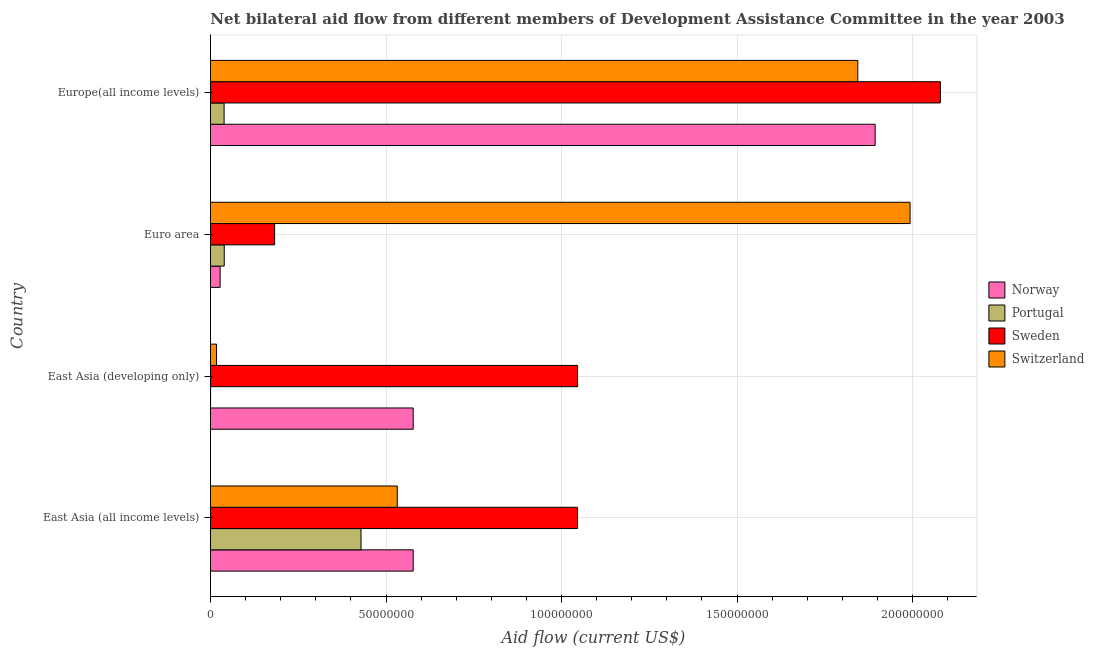Are the number of bars per tick equal to the number of legend labels?
Make the answer very short. Yes. Are the number of bars on each tick of the Y-axis equal?
Give a very brief answer. Yes. How many bars are there on the 4th tick from the top?
Offer a terse response. 4. How many bars are there on the 1st tick from the bottom?
Your answer should be very brief. 4. What is the label of the 3rd group of bars from the top?
Your response must be concise. East Asia (developing only). What is the amount of aid given by norway in East Asia (developing only)?
Ensure brevity in your answer.  5.78e+07. Across all countries, what is the maximum amount of aid given by portugal?
Provide a short and direct response. 4.29e+07. Across all countries, what is the minimum amount of aid given by portugal?
Your answer should be very brief. 3.00e+04. In which country was the amount of aid given by norway maximum?
Offer a very short reply. Europe(all income levels). In which country was the amount of aid given by norway minimum?
Offer a terse response. Euro area. What is the total amount of aid given by portugal in the graph?
Offer a very short reply. 5.07e+07. What is the difference between the amount of aid given by norway in Euro area and that in Europe(all income levels)?
Provide a short and direct response. -1.87e+08. What is the difference between the amount of aid given by sweden in Euro area and the amount of aid given by portugal in East Asia (developing only)?
Offer a very short reply. 1.82e+07. What is the average amount of aid given by sweden per country?
Provide a short and direct response. 1.09e+08. What is the difference between the amount of aid given by sweden and amount of aid given by norway in East Asia (all income levels)?
Ensure brevity in your answer.  4.68e+07. What is the ratio of the amount of aid given by portugal in East Asia (all income levels) to that in East Asia (developing only)?
Give a very brief answer. 1429.67. Is the difference between the amount of aid given by sweden in East Asia (all income levels) and East Asia (developing only) greater than the difference between the amount of aid given by switzerland in East Asia (all income levels) and East Asia (developing only)?
Your answer should be compact. No. What is the difference between the highest and the second highest amount of aid given by portugal?
Keep it short and to the point. 3.90e+07. What is the difference between the highest and the lowest amount of aid given by portugal?
Provide a succinct answer. 4.29e+07. In how many countries, is the amount of aid given by norway greater than the average amount of aid given by norway taken over all countries?
Make the answer very short. 1. Is the sum of the amount of aid given by norway in East Asia (all income levels) and Euro area greater than the maximum amount of aid given by switzerland across all countries?
Make the answer very short. No. Is it the case that in every country, the sum of the amount of aid given by norway and amount of aid given by switzerland is greater than the sum of amount of aid given by portugal and amount of aid given by sweden?
Offer a terse response. Yes. What does the 2nd bar from the top in East Asia (all income levels) represents?
Offer a terse response. Sweden. Are all the bars in the graph horizontal?
Your response must be concise. Yes. What is the difference between two consecutive major ticks on the X-axis?
Offer a terse response. 5.00e+07. Does the graph contain any zero values?
Your answer should be compact. No. Where does the legend appear in the graph?
Provide a short and direct response. Center right. How are the legend labels stacked?
Give a very brief answer. Vertical. What is the title of the graph?
Ensure brevity in your answer.  Net bilateral aid flow from different members of Development Assistance Committee in the year 2003. Does "Secondary general education" appear as one of the legend labels in the graph?
Provide a succinct answer. No. What is the label or title of the Y-axis?
Your answer should be very brief. Country. What is the Aid flow (current US$) in Norway in East Asia (all income levels)?
Provide a succinct answer. 5.78e+07. What is the Aid flow (current US$) of Portugal in East Asia (all income levels)?
Make the answer very short. 4.29e+07. What is the Aid flow (current US$) of Sweden in East Asia (all income levels)?
Ensure brevity in your answer.  1.05e+08. What is the Aid flow (current US$) of Switzerland in East Asia (all income levels)?
Ensure brevity in your answer.  5.32e+07. What is the Aid flow (current US$) in Norway in East Asia (developing only)?
Your answer should be compact. 5.78e+07. What is the Aid flow (current US$) in Portugal in East Asia (developing only)?
Your answer should be compact. 3.00e+04. What is the Aid flow (current US$) of Sweden in East Asia (developing only)?
Provide a succinct answer. 1.05e+08. What is the Aid flow (current US$) of Switzerland in East Asia (developing only)?
Your answer should be compact. 1.73e+06. What is the Aid flow (current US$) of Norway in Euro area?
Give a very brief answer. 2.75e+06. What is the Aid flow (current US$) of Portugal in Euro area?
Keep it short and to the point. 3.92e+06. What is the Aid flow (current US$) in Sweden in Euro area?
Provide a succinct answer. 1.83e+07. What is the Aid flow (current US$) in Switzerland in Euro area?
Your answer should be compact. 1.99e+08. What is the Aid flow (current US$) in Norway in Europe(all income levels)?
Make the answer very short. 1.89e+08. What is the Aid flow (current US$) of Portugal in Europe(all income levels)?
Your answer should be compact. 3.88e+06. What is the Aid flow (current US$) in Sweden in Europe(all income levels)?
Ensure brevity in your answer.  2.08e+08. What is the Aid flow (current US$) in Switzerland in Europe(all income levels)?
Ensure brevity in your answer.  1.84e+08. Across all countries, what is the maximum Aid flow (current US$) of Norway?
Ensure brevity in your answer.  1.89e+08. Across all countries, what is the maximum Aid flow (current US$) of Portugal?
Provide a short and direct response. 4.29e+07. Across all countries, what is the maximum Aid flow (current US$) of Sweden?
Your response must be concise. 2.08e+08. Across all countries, what is the maximum Aid flow (current US$) of Switzerland?
Ensure brevity in your answer.  1.99e+08. Across all countries, what is the minimum Aid flow (current US$) of Norway?
Ensure brevity in your answer.  2.75e+06. Across all countries, what is the minimum Aid flow (current US$) of Sweden?
Your response must be concise. 1.83e+07. Across all countries, what is the minimum Aid flow (current US$) of Switzerland?
Keep it short and to the point. 1.73e+06. What is the total Aid flow (current US$) in Norway in the graph?
Your response must be concise. 3.08e+08. What is the total Aid flow (current US$) of Portugal in the graph?
Offer a very short reply. 5.07e+07. What is the total Aid flow (current US$) of Sweden in the graph?
Your response must be concise. 4.35e+08. What is the total Aid flow (current US$) in Switzerland in the graph?
Offer a very short reply. 4.39e+08. What is the difference between the Aid flow (current US$) of Norway in East Asia (all income levels) and that in East Asia (developing only)?
Your response must be concise. 0. What is the difference between the Aid flow (current US$) of Portugal in East Asia (all income levels) and that in East Asia (developing only)?
Provide a succinct answer. 4.29e+07. What is the difference between the Aid flow (current US$) in Switzerland in East Asia (all income levels) and that in East Asia (developing only)?
Provide a short and direct response. 5.15e+07. What is the difference between the Aid flow (current US$) in Norway in East Asia (all income levels) and that in Euro area?
Your answer should be very brief. 5.50e+07. What is the difference between the Aid flow (current US$) of Portugal in East Asia (all income levels) and that in Euro area?
Ensure brevity in your answer.  3.90e+07. What is the difference between the Aid flow (current US$) in Sweden in East Asia (all income levels) and that in Euro area?
Your response must be concise. 8.63e+07. What is the difference between the Aid flow (current US$) in Switzerland in East Asia (all income levels) and that in Euro area?
Offer a terse response. -1.46e+08. What is the difference between the Aid flow (current US$) of Norway in East Asia (all income levels) and that in Europe(all income levels)?
Your answer should be compact. -1.32e+08. What is the difference between the Aid flow (current US$) of Portugal in East Asia (all income levels) and that in Europe(all income levels)?
Keep it short and to the point. 3.90e+07. What is the difference between the Aid flow (current US$) of Sweden in East Asia (all income levels) and that in Europe(all income levels)?
Provide a succinct answer. -1.03e+08. What is the difference between the Aid flow (current US$) in Switzerland in East Asia (all income levels) and that in Europe(all income levels)?
Your answer should be very brief. -1.31e+08. What is the difference between the Aid flow (current US$) of Norway in East Asia (developing only) and that in Euro area?
Ensure brevity in your answer.  5.50e+07. What is the difference between the Aid flow (current US$) of Portugal in East Asia (developing only) and that in Euro area?
Offer a very short reply. -3.89e+06. What is the difference between the Aid flow (current US$) of Sweden in East Asia (developing only) and that in Euro area?
Make the answer very short. 8.63e+07. What is the difference between the Aid flow (current US$) of Switzerland in East Asia (developing only) and that in Euro area?
Offer a terse response. -1.98e+08. What is the difference between the Aid flow (current US$) in Norway in East Asia (developing only) and that in Europe(all income levels)?
Ensure brevity in your answer.  -1.32e+08. What is the difference between the Aid flow (current US$) in Portugal in East Asia (developing only) and that in Europe(all income levels)?
Make the answer very short. -3.85e+06. What is the difference between the Aid flow (current US$) in Sweden in East Asia (developing only) and that in Europe(all income levels)?
Ensure brevity in your answer.  -1.03e+08. What is the difference between the Aid flow (current US$) of Switzerland in East Asia (developing only) and that in Europe(all income levels)?
Give a very brief answer. -1.83e+08. What is the difference between the Aid flow (current US$) of Norway in Euro area and that in Europe(all income levels)?
Ensure brevity in your answer.  -1.87e+08. What is the difference between the Aid flow (current US$) of Portugal in Euro area and that in Europe(all income levels)?
Make the answer very short. 4.00e+04. What is the difference between the Aid flow (current US$) in Sweden in Euro area and that in Europe(all income levels)?
Give a very brief answer. -1.90e+08. What is the difference between the Aid flow (current US$) of Switzerland in Euro area and that in Europe(all income levels)?
Provide a succinct answer. 1.49e+07. What is the difference between the Aid flow (current US$) in Norway in East Asia (all income levels) and the Aid flow (current US$) in Portugal in East Asia (developing only)?
Keep it short and to the point. 5.77e+07. What is the difference between the Aid flow (current US$) in Norway in East Asia (all income levels) and the Aid flow (current US$) in Sweden in East Asia (developing only)?
Provide a short and direct response. -4.68e+07. What is the difference between the Aid flow (current US$) in Norway in East Asia (all income levels) and the Aid flow (current US$) in Switzerland in East Asia (developing only)?
Offer a very short reply. 5.60e+07. What is the difference between the Aid flow (current US$) in Portugal in East Asia (all income levels) and the Aid flow (current US$) in Sweden in East Asia (developing only)?
Make the answer very short. -6.17e+07. What is the difference between the Aid flow (current US$) in Portugal in East Asia (all income levels) and the Aid flow (current US$) in Switzerland in East Asia (developing only)?
Provide a succinct answer. 4.12e+07. What is the difference between the Aid flow (current US$) in Sweden in East Asia (all income levels) and the Aid flow (current US$) in Switzerland in East Asia (developing only)?
Keep it short and to the point. 1.03e+08. What is the difference between the Aid flow (current US$) of Norway in East Asia (all income levels) and the Aid flow (current US$) of Portugal in Euro area?
Your answer should be very brief. 5.38e+07. What is the difference between the Aid flow (current US$) in Norway in East Asia (all income levels) and the Aid flow (current US$) in Sweden in Euro area?
Keep it short and to the point. 3.95e+07. What is the difference between the Aid flow (current US$) in Norway in East Asia (all income levels) and the Aid flow (current US$) in Switzerland in Euro area?
Give a very brief answer. -1.42e+08. What is the difference between the Aid flow (current US$) of Portugal in East Asia (all income levels) and the Aid flow (current US$) of Sweden in Euro area?
Offer a very short reply. 2.46e+07. What is the difference between the Aid flow (current US$) in Portugal in East Asia (all income levels) and the Aid flow (current US$) in Switzerland in Euro area?
Give a very brief answer. -1.56e+08. What is the difference between the Aid flow (current US$) of Sweden in East Asia (all income levels) and the Aid flow (current US$) of Switzerland in Euro area?
Your answer should be compact. -9.47e+07. What is the difference between the Aid flow (current US$) of Norway in East Asia (all income levels) and the Aid flow (current US$) of Portugal in Europe(all income levels)?
Make the answer very short. 5.39e+07. What is the difference between the Aid flow (current US$) of Norway in East Asia (all income levels) and the Aid flow (current US$) of Sweden in Europe(all income levels)?
Your response must be concise. -1.50e+08. What is the difference between the Aid flow (current US$) of Norway in East Asia (all income levels) and the Aid flow (current US$) of Switzerland in Europe(all income levels)?
Offer a very short reply. -1.27e+08. What is the difference between the Aid flow (current US$) in Portugal in East Asia (all income levels) and the Aid flow (current US$) in Sweden in Europe(all income levels)?
Offer a very short reply. -1.65e+08. What is the difference between the Aid flow (current US$) of Portugal in East Asia (all income levels) and the Aid flow (current US$) of Switzerland in Europe(all income levels)?
Make the answer very short. -1.42e+08. What is the difference between the Aid flow (current US$) in Sweden in East Asia (all income levels) and the Aid flow (current US$) in Switzerland in Europe(all income levels)?
Make the answer very short. -7.98e+07. What is the difference between the Aid flow (current US$) in Norway in East Asia (developing only) and the Aid flow (current US$) in Portugal in Euro area?
Give a very brief answer. 5.38e+07. What is the difference between the Aid flow (current US$) of Norway in East Asia (developing only) and the Aid flow (current US$) of Sweden in Euro area?
Make the answer very short. 3.95e+07. What is the difference between the Aid flow (current US$) of Norway in East Asia (developing only) and the Aid flow (current US$) of Switzerland in Euro area?
Provide a short and direct response. -1.42e+08. What is the difference between the Aid flow (current US$) in Portugal in East Asia (developing only) and the Aid flow (current US$) in Sweden in Euro area?
Your answer should be very brief. -1.82e+07. What is the difference between the Aid flow (current US$) in Portugal in East Asia (developing only) and the Aid flow (current US$) in Switzerland in Euro area?
Your answer should be compact. -1.99e+08. What is the difference between the Aid flow (current US$) in Sweden in East Asia (developing only) and the Aid flow (current US$) in Switzerland in Euro area?
Give a very brief answer. -9.47e+07. What is the difference between the Aid flow (current US$) of Norway in East Asia (developing only) and the Aid flow (current US$) of Portugal in Europe(all income levels)?
Your answer should be very brief. 5.39e+07. What is the difference between the Aid flow (current US$) of Norway in East Asia (developing only) and the Aid flow (current US$) of Sweden in Europe(all income levels)?
Offer a very short reply. -1.50e+08. What is the difference between the Aid flow (current US$) of Norway in East Asia (developing only) and the Aid flow (current US$) of Switzerland in Europe(all income levels)?
Your answer should be very brief. -1.27e+08. What is the difference between the Aid flow (current US$) in Portugal in East Asia (developing only) and the Aid flow (current US$) in Sweden in Europe(all income levels)?
Provide a succinct answer. -2.08e+08. What is the difference between the Aid flow (current US$) in Portugal in East Asia (developing only) and the Aid flow (current US$) in Switzerland in Europe(all income levels)?
Offer a terse response. -1.84e+08. What is the difference between the Aid flow (current US$) of Sweden in East Asia (developing only) and the Aid flow (current US$) of Switzerland in Europe(all income levels)?
Keep it short and to the point. -7.98e+07. What is the difference between the Aid flow (current US$) in Norway in Euro area and the Aid flow (current US$) in Portugal in Europe(all income levels)?
Your answer should be compact. -1.13e+06. What is the difference between the Aid flow (current US$) in Norway in Euro area and the Aid flow (current US$) in Sweden in Europe(all income levels)?
Keep it short and to the point. -2.05e+08. What is the difference between the Aid flow (current US$) in Norway in Euro area and the Aid flow (current US$) in Switzerland in Europe(all income levels)?
Make the answer very short. -1.82e+08. What is the difference between the Aid flow (current US$) in Portugal in Euro area and the Aid flow (current US$) in Sweden in Europe(all income levels)?
Make the answer very short. -2.04e+08. What is the difference between the Aid flow (current US$) of Portugal in Euro area and the Aid flow (current US$) of Switzerland in Europe(all income levels)?
Your answer should be very brief. -1.80e+08. What is the difference between the Aid flow (current US$) of Sweden in Euro area and the Aid flow (current US$) of Switzerland in Europe(all income levels)?
Make the answer very short. -1.66e+08. What is the average Aid flow (current US$) in Norway per country?
Offer a terse response. 7.69e+07. What is the average Aid flow (current US$) of Portugal per country?
Keep it short and to the point. 1.27e+07. What is the average Aid flow (current US$) of Sweden per country?
Keep it short and to the point. 1.09e+08. What is the average Aid flow (current US$) in Switzerland per country?
Provide a short and direct response. 1.10e+08. What is the difference between the Aid flow (current US$) in Norway and Aid flow (current US$) in Portugal in East Asia (all income levels)?
Provide a succinct answer. 1.49e+07. What is the difference between the Aid flow (current US$) of Norway and Aid flow (current US$) of Sweden in East Asia (all income levels)?
Your response must be concise. -4.68e+07. What is the difference between the Aid flow (current US$) in Norway and Aid flow (current US$) in Switzerland in East Asia (all income levels)?
Give a very brief answer. 4.54e+06. What is the difference between the Aid flow (current US$) in Portugal and Aid flow (current US$) in Sweden in East Asia (all income levels)?
Provide a short and direct response. -6.17e+07. What is the difference between the Aid flow (current US$) of Portugal and Aid flow (current US$) of Switzerland in East Asia (all income levels)?
Keep it short and to the point. -1.03e+07. What is the difference between the Aid flow (current US$) of Sweden and Aid flow (current US$) of Switzerland in East Asia (all income levels)?
Ensure brevity in your answer.  5.14e+07. What is the difference between the Aid flow (current US$) of Norway and Aid flow (current US$) of Portugal in East Asia (developing only)?
Make the answer very short. 5.77e+07. What is the difference between the Aid flow (current US$) of Norway and Aid flow (current US$) of Sweden in East Asia (developing only)?
Provide a succinct answer. -4.68e+07. What is the difference between the Aid flow (current US$) of Norway and Aid flow (current US$) of Switzerland in East Asia (developing only)?
Make the answer very short. 5.60e+07. What is the difference between the Aid flow (current US$) of Portugal and Aid flow (current US$) of Sweden in East Asia (developing only)?
Make the answer very short. -1.05e+08. What is the difference between the Aid flow (current US$) in Portugal and Aid flow (current US$) in Switzerland in East Asia (developing only)?
Your response must be concise. -1.70e+06. What is the difference between the Aid flow (current US$) of Sweden and Aid flow (current US$) of Switzerland in East Asia (developing only)?
Keep it short and to the point. 1.03e+08. What is the difference between the Aid flow (current US$) in Norway and Aid flow (current US$) in Portugal in Euro area?
Give a very brief answer. -1.17e+06. What is the difference between the Aid flow (current US$) in Norway and Aid flow (current US$) in Sweden in Euro area?
Give a very brief answer. -1.55e+07. What is the difference between the Aid flow (current US$) in Norway and Aid flow (current US$) in Switzerland in Euro area?
Make the answer very short. -1.97e+08. What is the difference between the Aid flow (current US$) in Portugal and Aid flow (current US$) in Sweden in Euro area?
Offer a terse response. -1.44e+07. What is the difference between the Aid flow (current US$) of Portugal and Aid flow (current US$) of Switzerland in Euro area?
Your answer should be very brief. -1.95e+08. What is the difference between the Aid flow (current US$) of Sweden and Aid flow (current US$) of Switzerland in Euro area?
Ensure brevity in your answer.  -1.81e+08. What is the difference between the Aid flow (current US$) of Norway and Aid flow (current US$) of Portugal in Europe(all income levels)?
Your answer should be very brief. 1.85e+08. What is the difference between the Aid flow (current US$) in Norway and Aid flow (current US$) in Sweden in Europe(all income levels)?
Provide a succinct answer. -1.86e+07. What is the difference between the Aid flow (current US$) of Norway and Aid flow (current US$) of Switzerland in Europe(all income levels)?
Your answer should be very brief. 4.94e+06. What is the difference between the Aid flow (current US$) of Portugal and Aid flow (current US$) of Sweden in Europe(all income levels)?
Ensure brevity in your answer.  -2.04e+08. What is the difference between the Aid flow (current US$) in Portugal and Aid flow (current US$) in Switzerland in Europe(all income levels)?
Your answer should be very brief. -1.81e+08. What is the difference between the Aid flow (current US$) of Sweden and Aid flow (current US$) of Switzerland in Europe(all income levels)?
Offer a terse response. 2.35e+07. What is the ratio of the Aid flow (current US$) in Portugal in East Asia (all income levels) to that in East Asia (developing only)?
Ensure brevity in your answer.  1429.67. What is the ratio of the Aid flow (current US$) in Sweden in East Asia (all income levels) to that in East Asia (developing only)?
Your response must be concise. 1. What is the ratio of the Aid flow (current US$) of Switzerland in East Asia (all income levels) to that in East Asia (developing only)?
Your answer should be compact. 30.76. What is the ratio of the Aid flow (current US$) of Portugal in East Asia (all income levels) to that in Euro area?
Your answer should be very brief. 10.94. What is the ratio of the Aid flow (current US$) of Sweden in East Asia (all income levels) to that in Euro area?
Your answer should be compact. 5.72. What is the ratio of the Aid flow (current US$) of Switzerland in East Asia (all income levels) to that in Euro area?
Give a very brief answer. 0.27. What is the ratio of the Aid flow (current US$) of Norway in East Asia (all income levels) to that in Europe(all income levels)?
Your answer should be very brief. 0.3. What is the ratio of the Aid flow (current US$) of Portugal in East Asia (all income levels) to that in Europe(all income levels)?
Make the answer very short. 11.05. What is the ratio of the Aid flow (current US$) in Sweden in East Asia (all income levels) to that in Europe(all income levels)?
Provide a short and direct response. 0.5. What is the ratio of the Aid flow (current US$) in Switzerland in East Asia (all income levels) to that in Europe(all income levels)?
Ensure brevity in your answer.  0.29. What is the ratio of the Aid flow (current US$) in Norway in East Asia (developing only) to that in Euro area?
Ensure brevity in your answer.  21. What is the ratio of the Aid flow (current US$) of Portugal in East Asia (developing only) to that in Euro area?
Offer a very short reply. 0.01. What is the ratio of the Aid flow (current US$) in Sweden in East Asia (developing only) to that in Euro area?
Your answer should be compact. 5.72. What is the ratio of the Aid flow (current US$) of Switzerland in East Asia (developing only) to that in Euro area?
Give a very brief answer. 0.01. What is the ratio of the Aid flow (current US$) in Norway in East Asia (developing only) to that in Europe(all income levels)?
Make the answer very short. 0.3. What is the ratio of the Aid flow (current US$) in Portugal in East Asia (developing only) to that in Europe(all income levels)?
Give a very brief answer. 0.01. What is the ratio of the Aid flow (current US$) of Sweden in East Asia (developing only) to that in Europe(all income levels)?
Make the answer very short. 0.5. What is the ratio of the Aid flow (current US$) in Switzerland in East Asia (developing only) to that in Europe(all income levels)?
Your answer should be compact. 0.01. What is the ratio of the Aid flow (current US$) in Norway in Euro area to that in Europe(all income levels)?
Ensure brevity in your answer.  0.01. What is the ratio of the Aid flow (current US$) of Portugal in Euro area to that in Europe(all income levels)?
Ensure brevity in your answer.  1.01. What is the ratio of the Aid flow (current US$) of Sweden in Euro area to that in Europe(all income levels)?
Your answer should be compact. 0.09. What is the ratio of the Aid flow (current US$) in Switzerland in Euro area to that in Europe(all income levels)?
Keep it short and to the point. 1.08. What is the difference between the highest and the second highest Aid flow (current US$) of Norway?
Ensure brevity in your answer.  1.32e+08. What is the difference between the highest and the second highest Aid flow (current US$) of Portugal?
Give a very brief answer. 3.90e+07. What is the difference between the highest and the second highest Aid flow (current US$) of Sweden?
Offer a very short reply. 1.03e+08. What is the difference between the highest and the second highest Aid flow (current US$) of Switzerland?
Offer a very short reply. 1.49e+07. What is the difference between the highest and the lowest Aid flow (current US$) of Norway?
Provide a succinct answer. 1.87e+08. What is the difference between the highest and the lowest Aid flow (current US$) in Portugal?
Give a very brief answer. 4.29e+07. What is the difference between the highest and the lowest Aid flow (current US$) in Sweden?
Make the answer very short. 1.90e+08. What is the difference between the highest and the lowest Aid flow (current US$) of Switzerland?
Give a very brief answer. 1.98e+08. 